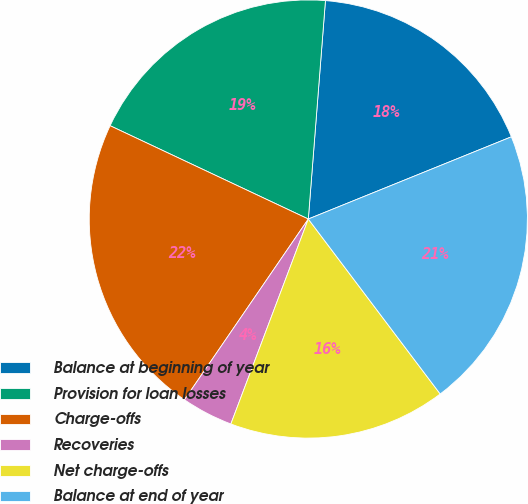<chart> <loc_0><loc_0><loc_500><loc_500><pie_chart><fcel>Balance at beginning of year<fcel>Provision for loan losses<fcel>Charge-offs<fcel>Recoveries<fcel>Net charge-offs<fcel>Balance at end of year<nl><fcel>17.63%<fcel>19.24%<fcel>22.44%<fcel>3.81%<fcel>16.03%<fcel>20.84%<nl></chart> 